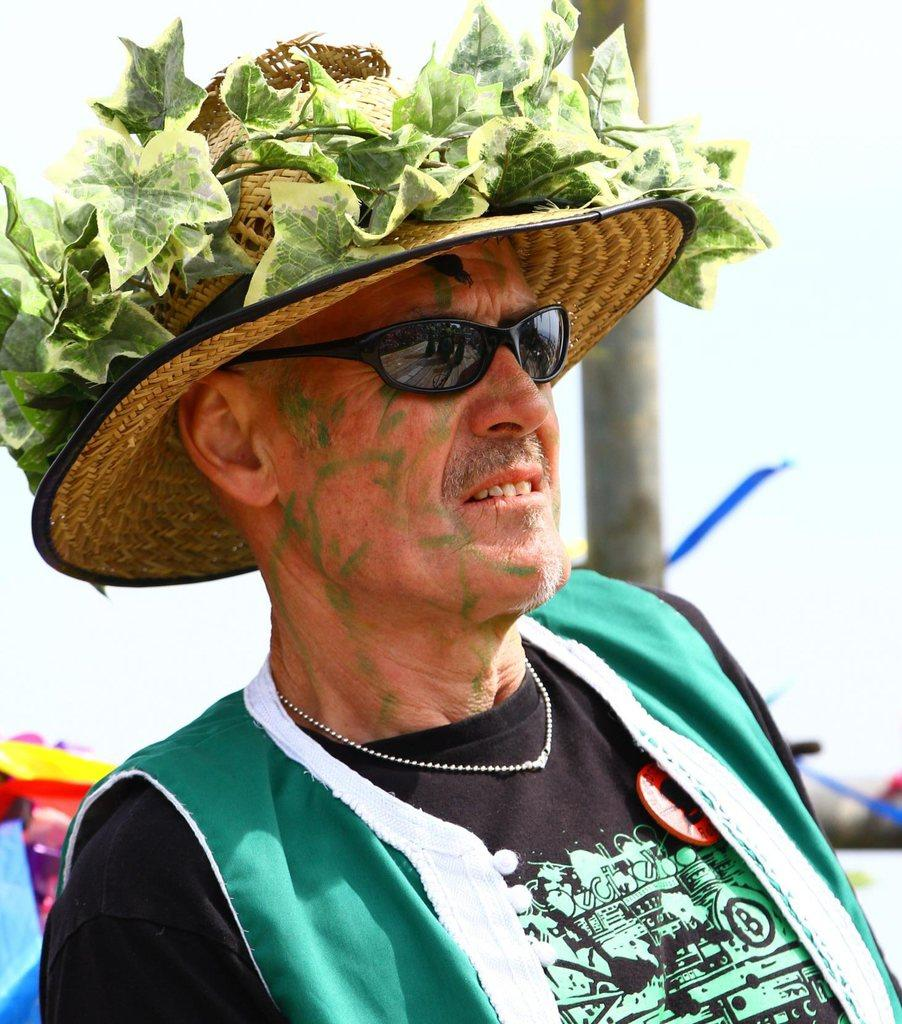Who is present in the image? There is a man in the image. What is the man wearing on his face? The man is wearing spectacles. What type of headwear is the man wearing? The man is wearing a hat. What is visible at the top of the image? The sky is visible at the top of the image. What way is the man reading the book in the image? There is no book present in the image, so it is not possible to determine how the man might be reading. 